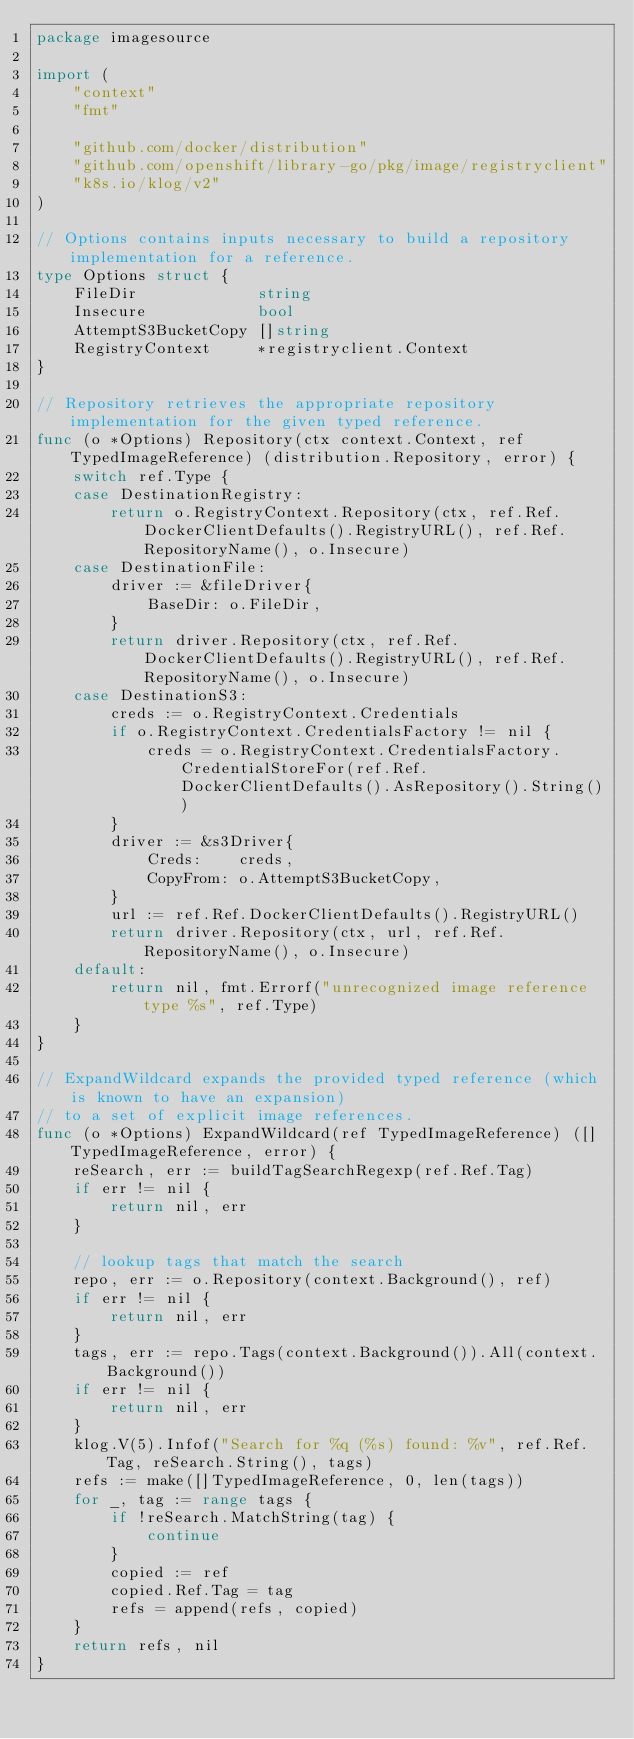<code> <loc_0><loc_0><loc_500><loc_500><_Go_>package imagesource

import (
	"context"
	"fmt"

	"github.com/docker/distribution"
	"github.com/openshift/library-go/pkg/image/registryclient"
	"k8s.io/klog/v2"
)

// Options contains inputs necessary to build a repository implementation for a reference.
type Options struct {
	FileDir             string
	Insecure            bool
	AttemptS3BucketCopy []string
	RegistryContext     *registryclient.Context
}

// Repository retrieves the appropriate repository implementation for the given typed reference.
func (o *Options) Repository(ctx context.Context, ref TypedImageReference) (distribution.Repository, error) {
	switch ref.Type {
	case DestinationRegistry:
		return o.RegistryContext.Repository(ctx, ref.Ref.DockerClientDefaults().RegistryURL(), ref.Ref.RepositoryName(), o.Insecure)
	case DestinationFile:
		driver := &fileDriver{
			BaseDir: o.FileDir,
		}
		return driver.Repository(ctx, ref.Ref.DockerClientDefaults().RegistryURL(), ref.Ref.RepositoryName(), o.Insecure)
	case DestinationS3:
		creds := o.RegistryContext.Credentials
		if o.RegistryContext.CredentialsFactory != nil {
			creds = o.RegistryContext.CredentialsFactory.CredentialStoreFor(ref.Ref.DockerClientDefaults().AsRepository().String())
		}
		driver := &s3Driver{
			Creds:    creds,
			CopyFrom: o.AttemptS3BucketCopy,
		}
		url := ref.Ref.DockerClientDefaults().RegistryURL()
		return driver.Repository(ctx, url, ref.Ref.RepositoryName(), o.Insecure)
	default:
		return nil, fmt.Errorf("unrecognized image reference type %s", ref.Type)
	}
}

// ExpandWildcard expands the provided typed reference (which is known to have an expansion)
// to a set of explicit image references.
func (o *Options) ExpandWildcard(ref TypedImageReference) ([]TypedImageReference, error) {
	reSearch, err := buildTagSearchRegexp(ref.Ref.Tag)
	if err != nil {
		return nil, err
	}

	// lookup tags that match the search
	repo, err := o.Repository(context.Background(), ref)
	if err != nil {
		return nil, err
	}
	tags, err := repo.Tags(context.Background()).All(context.Background())
	if err != nil {
		return nil, err
	}
	klog.V(5).Infof("Search for %q (%s) found: %v", ref.Ref.Tag, reSearch.String(), tags)
	refs := make([]TypedImageReference, 0, len(tags))
	for _, tag := range tags {
		if !reSearch.MatchString(tag) {
			continue
		}
		copied := ref
		copied.Ref.Tag = tag
		refs = append(refs, copied)
	}
	return refs, nil
}
</code> 